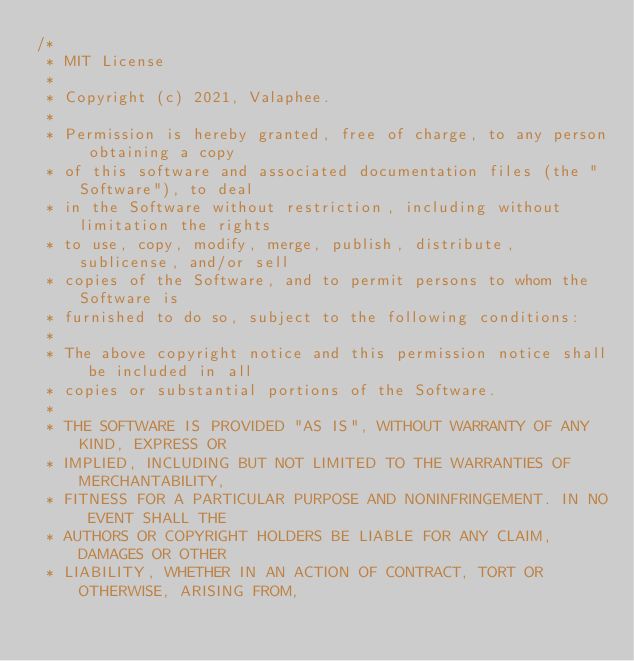Convert code to text. <code><loc_0><loc_0><loc_500><loc_500><_Kotlin_>/*
 * MIT License
 *
 * Copyright (c) 2021, Valaphee.
 *
 * Permission is hereby granted, free of charge, to any person obtaining a copy
 * of this software and associated documentation files (the "Software"), to deal
 * in the Software without restriction, including without limitation the rights
 * to use, copy, modify, merge, publish, distribute, sublicense, and/or sell
 * copies of the Software, and to permit persons to whom the Software is
 * furnished to do so, subject to the following conditions:
 *
 * The above copyright notice and this permission notice shall be included in all
 * copies or substantial portions of the Software.
 *
 * THE SOFTWARE IS PROVIDED "AS IS", WITHOUT WARRANTY OF ANY KIND, EXPRESS OR
 * IMPLIED, INCLUDING BUT NOT LIMITED TO THE WARRANTIES OF MERCHANTABILITY,
 * FITNESS FOR A PARTICULAR PURPOSE AND NONINFRINGEMENT. IN NO EVENT SHALL THE
 * AUTHORS OR COPYRIGHT HOLDERS BE LIABLE FOR ANY CLAIM, DAMAGES OR OTHER
 * LIABILITY, WHETHER IN AN ACTION OF CONTRACT, TORT OR OTHERWISE, ARISING FROM,</code> 